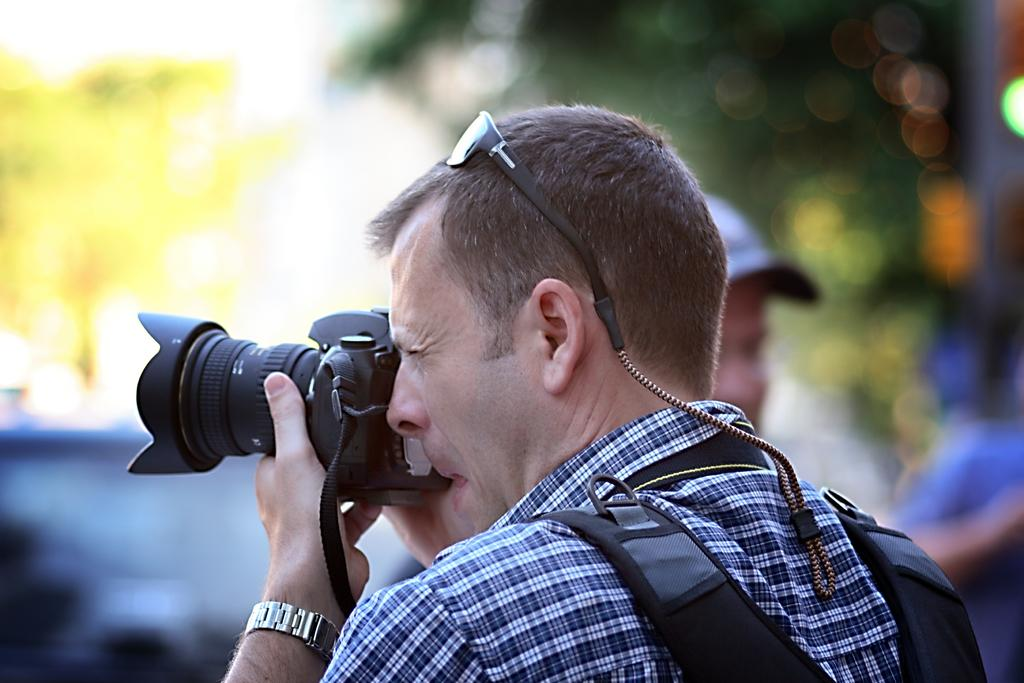Who is present in the image? There is a man in the image. What is the man doing in the image? The man is capturing a photo. What type of copper material is used to create the flavor in the image? There is no copper or flavor present in the image; it only features a man capturing a photo. 